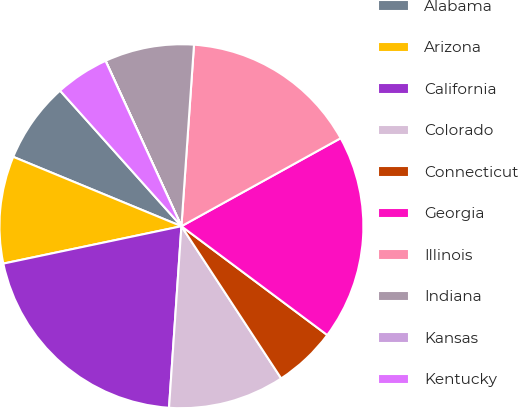Convert chart to OTSL. <chart><loc_0><loc_0><loc_500><loc_500><pie_chart><fcel>Alabama<fcel>Arizona<fcel>California<fcel>Colorado<fcel>Connecticut<fcel>Georgia<fcel>Illinois<fcel>Indiana<fcel>Kansas<fcel>Kentucky<nl><fcel>7.15%<fcel>9.52%<fcel>20.62%<fcel>10.32%<fcel>5.56%<fcel>18.24%<fcel>15.86%<fcel>7.94%<fcel>0.01%<fcel>4.77%<nl></chart> 